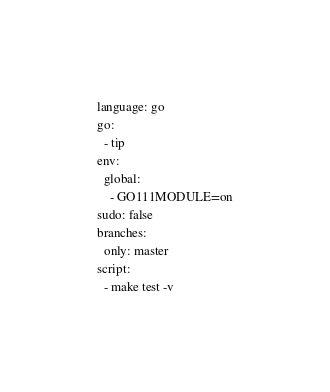Convert code to text. <code><loc_0><loc_0><loc_500><loc_500><_YAML_>language: go
go:
  - tip
env:
  global:
    - GO111MODULE=on
sudo: false
branches:
  only: master
script:
  - make test -v</code> 